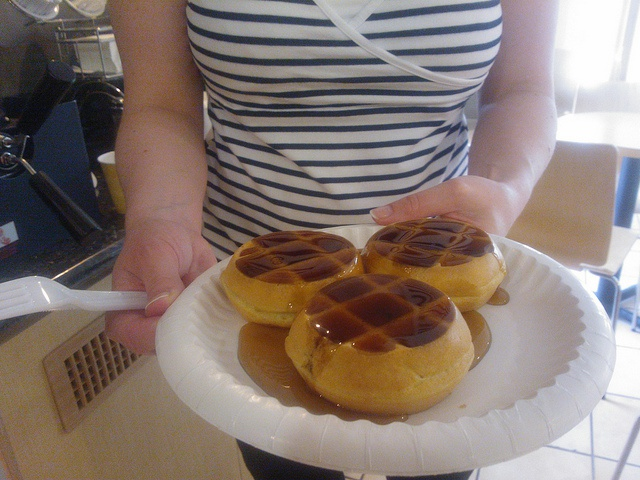Describe the objects in this image and their specific colors. I can see people in darkgreen, darkgray, gray, and black tones, chair in darkgreen, gray, darkgray, and lightgray tones, fork in darkgreen, darkgray, and gray tones, chair in lightgray and darkgreen tones, and cup in darkgreen, olive, maroon, darkgray, and gray tones in this image. 